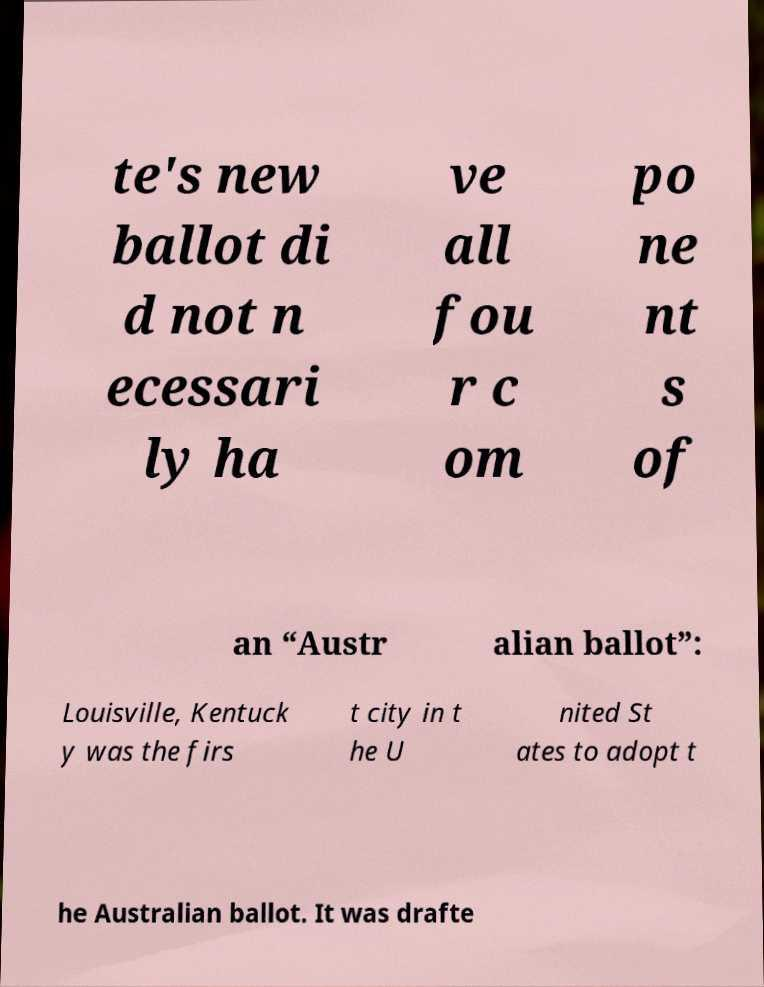What messages or text are displayed in this image? I need them in a readable, typed format. te's new ballot di d not n ecessari ly ha ve all fou r c om po ne nt s of an “Austr alian ballot”: Louisville, Kentuck y was the firs t city in t he U nited St ates to adopt t he Australian ballot. It was drafte 